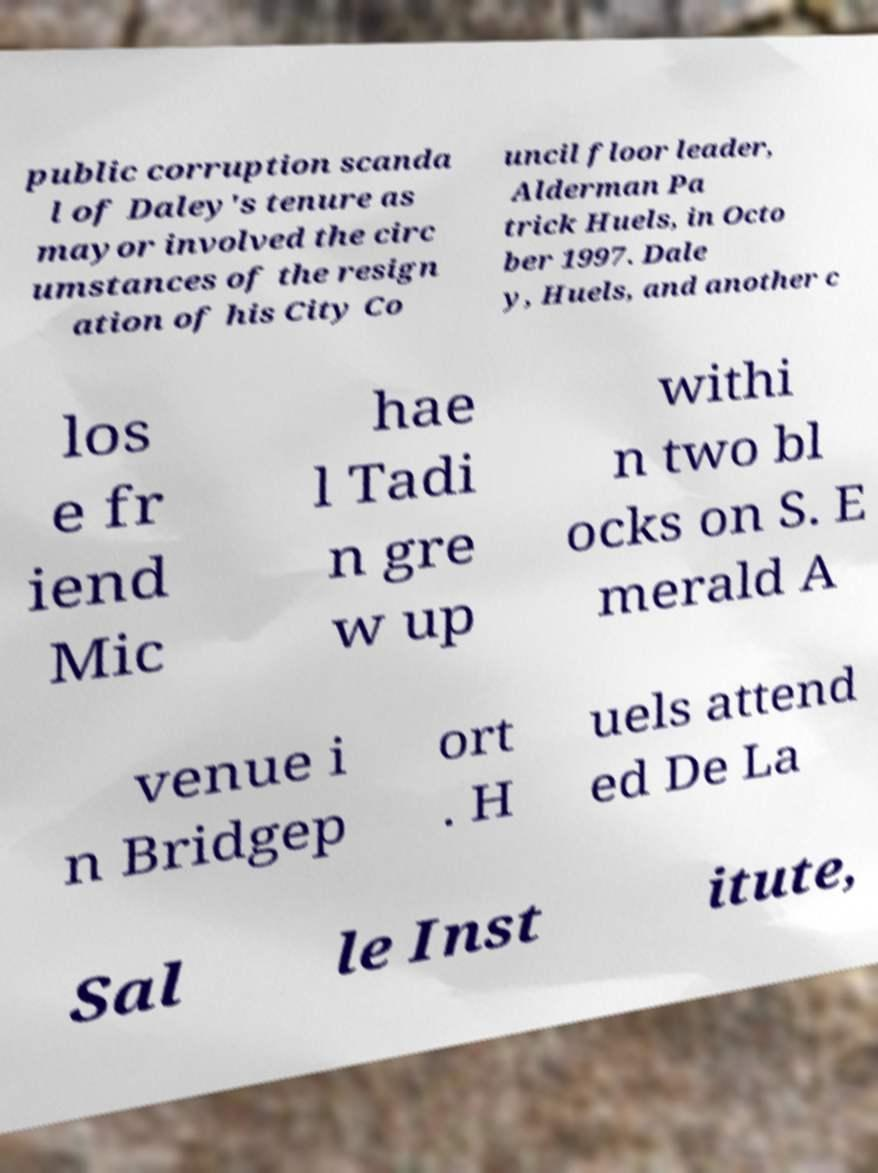Please read and relay the text visible in this image. What does it say? public corruption scanda l of Daley's tenure as mayor involved the circ umstances of the resign ation of his City Co uncil floor leader, Alderman Pa trick Huels, in Octo ber 1997. Dale y, Huels, and another c los e fr iend Mic hae l Tadi n gre w up withi n two bl ocks on S. E merald A venue i n Bridgep ort . H uels attend ed De La Sal le Inst itute, 